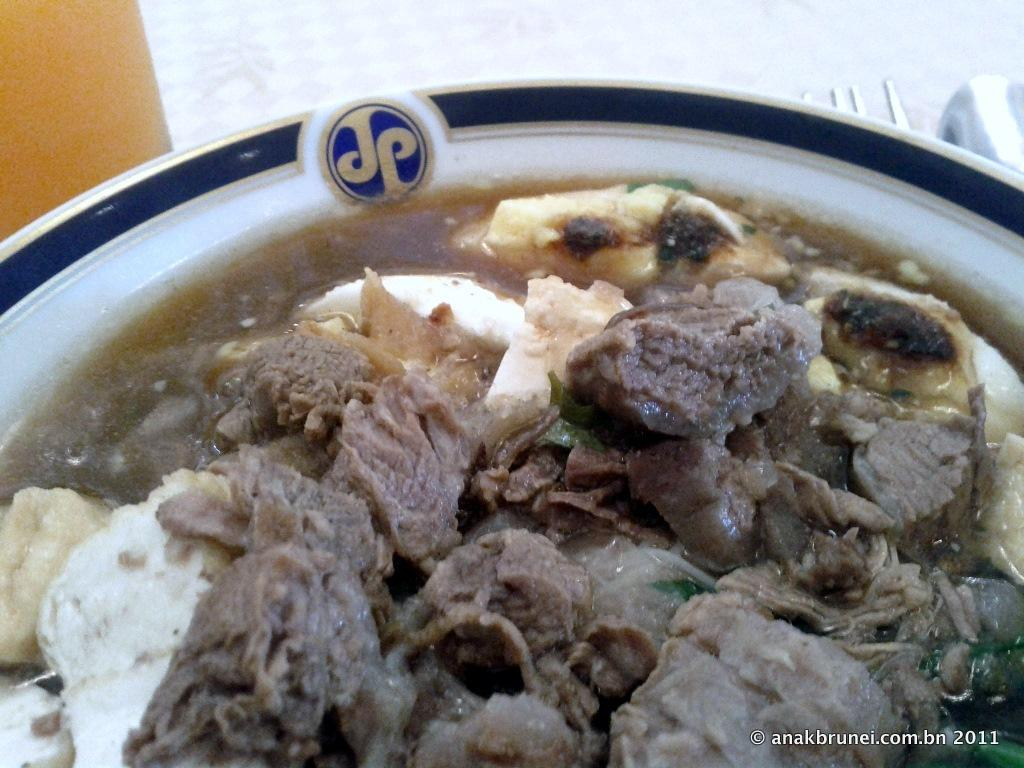What is in the bowl that is visible in the image? There are food items in a bowl in the image. What additional detail can be seen on the bowl? There is a letter visible on the bowl. What utensil is present in the image? There is a fork in the image. What can be used for cleaning or wiping in the image? There is tissue paper in the image. What type of surface is the object placed on in the image? There is an object on a wooden surface in the image. Can you describe the fight between the sheep and the wheel in the image? There is no fight between a sheep and a wheel present in the image. 